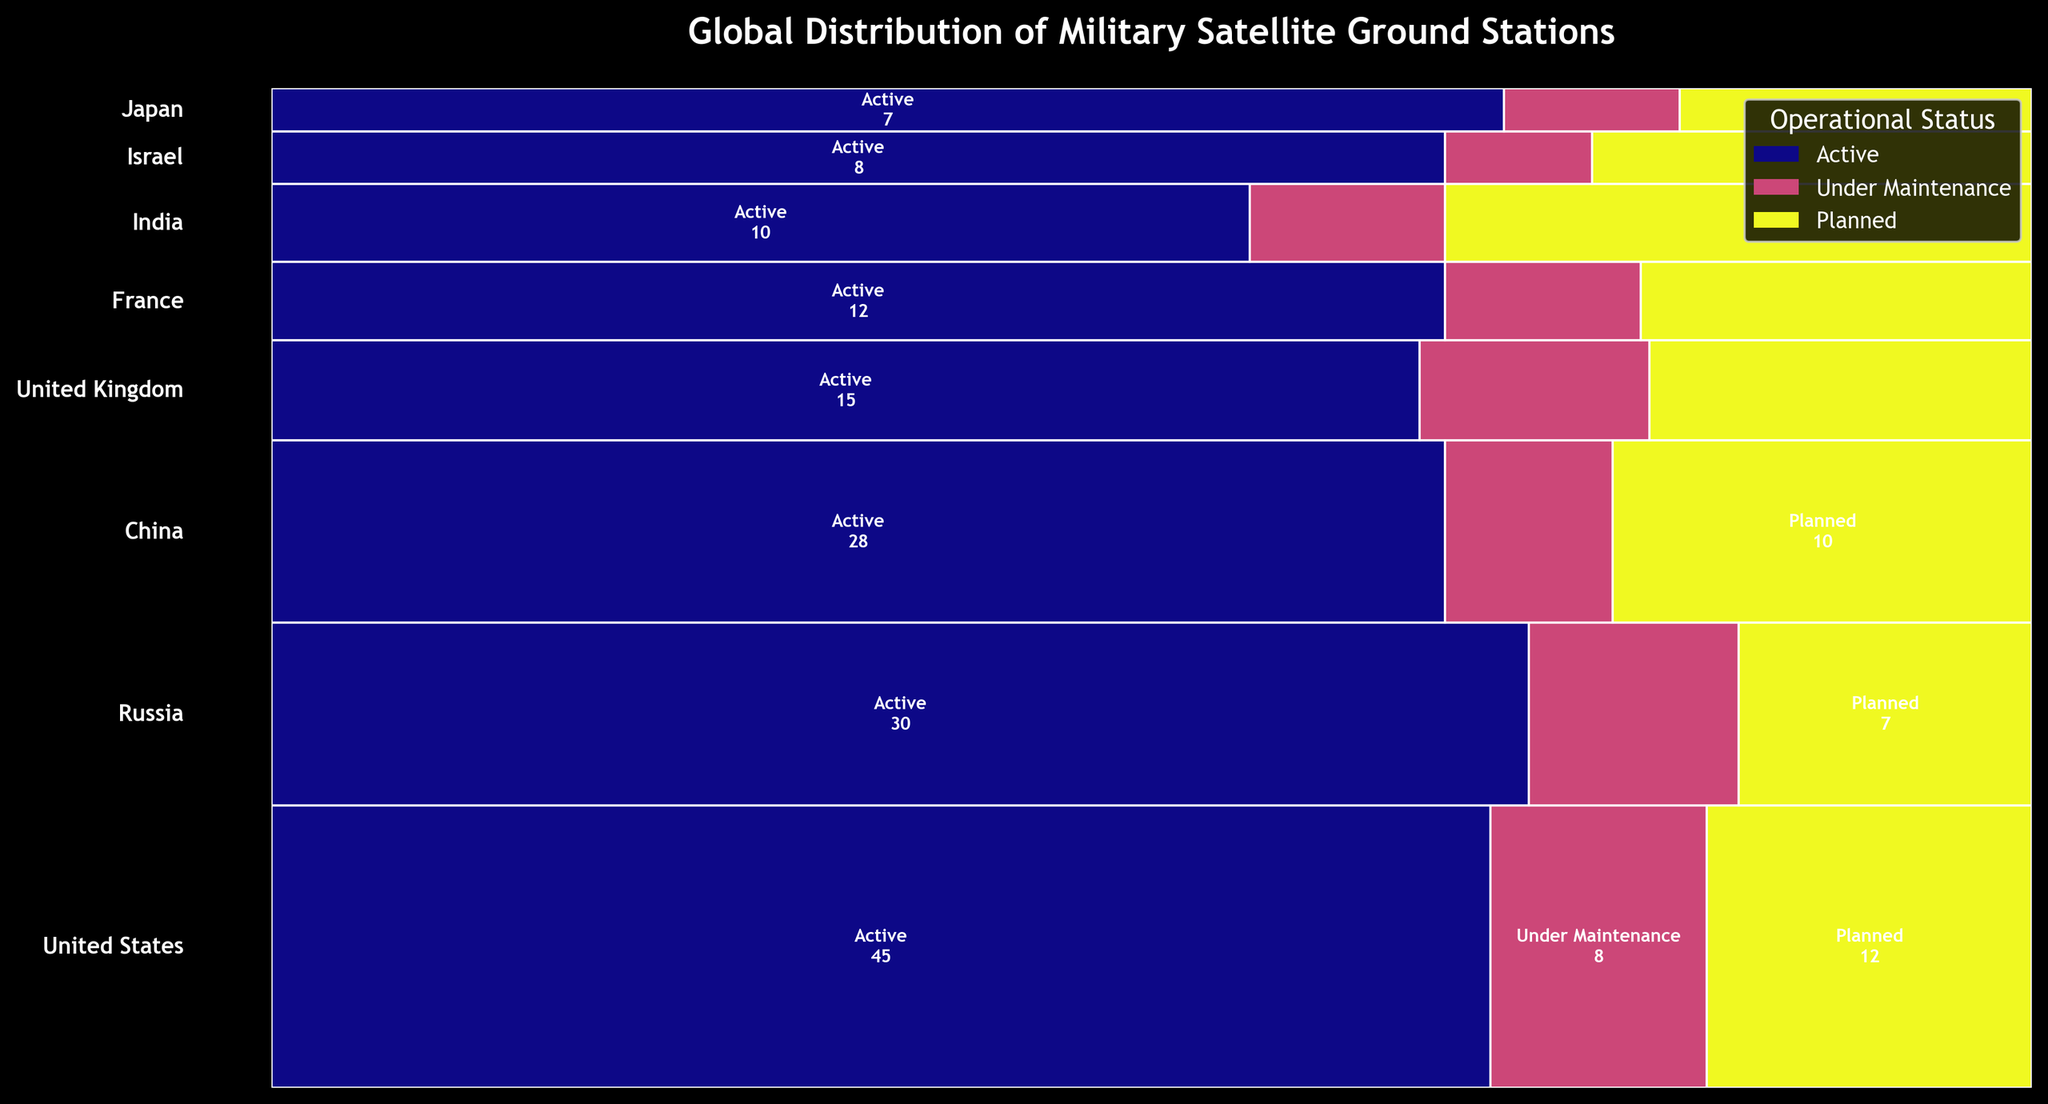Which country has the highest number of active ground stations? To determine the country with the highest number of active ground stations, look at the segment labeled "Active" for each country and compare their sizes. The United States has the largest "Active" segment.
Answer: United States How many total ground stations are there in Russia? Sum up the number of active, under maintenance, and planned ground stations in Russia: 30 (active) + 5 (under maintenance) + 7 (planned). This gives a total of 42.
Answer: 42 What is the combined total of planned ground stations in China and India? Add the planned ground stations in China (10) and India (6). This results in 10 + 6 = 16.
Answer: 16 Which operational status has the smallest representation in the United Kingdom? Compare the sizes of the segments for active, under maintenance, and planned ground stations in the United Kingdom. The "Under Maintenance" segment is the smallest.
Answer: Under Maintenance What percentage of Japan's ground stations are under maintenance? First, find the total number of ground stations in Japan: 7 (active) + 1 (under maintenance) + 2 (planned) = 10. Then, calculate the percentage of under maintenance stations: (1/10) * 100 = 10%.
Answer: 10% Which country has the exact same number of under maintenance stations as India? Look at the "Under Maintenance" segments and numbers for each country. Both India and Japan have 2 under maintenance stations.
Answer: Japan What is the difference between the number of active and planned ground stations in France? Subtract the number of planned ground stations from the number of active ground stations in France: 12 (active) - 4 (planned) = 8.
Answer: 8 How does the number of ground stations under maintenance in the United States compare to those in Russia? Compare the "Under Maintenance" segments for the United States (8) and Russia (5). The United States has more under maintenance stations than Russia.
Answer: United States has more Which set of countries have more total active stations combined, China and France, or Russia and Israel? Calculate the combined total of active stations for each set of countries: China (28) + France (12) = 40. Russia (30) + Israel (8) = 38. China and France have more.
Answer: China and France What is the overall trend in planned ground stations among all countries? Look at the "Planned" segments for all countries. Most countries have a moderate number of planned ground stations compared to active and under maintenance stations, indicating steady future expansion.
Answer: Moderate planned expansion 